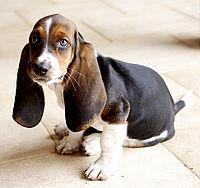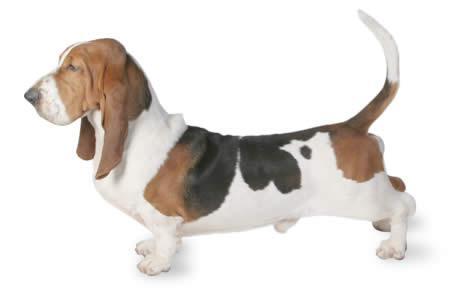The first image is the image on the left, the second image is the image on the right. Considering the images on both sides, is "One image shows a dog's body in profile, turned toward the left." valid? Answer yes or no. Yes. 